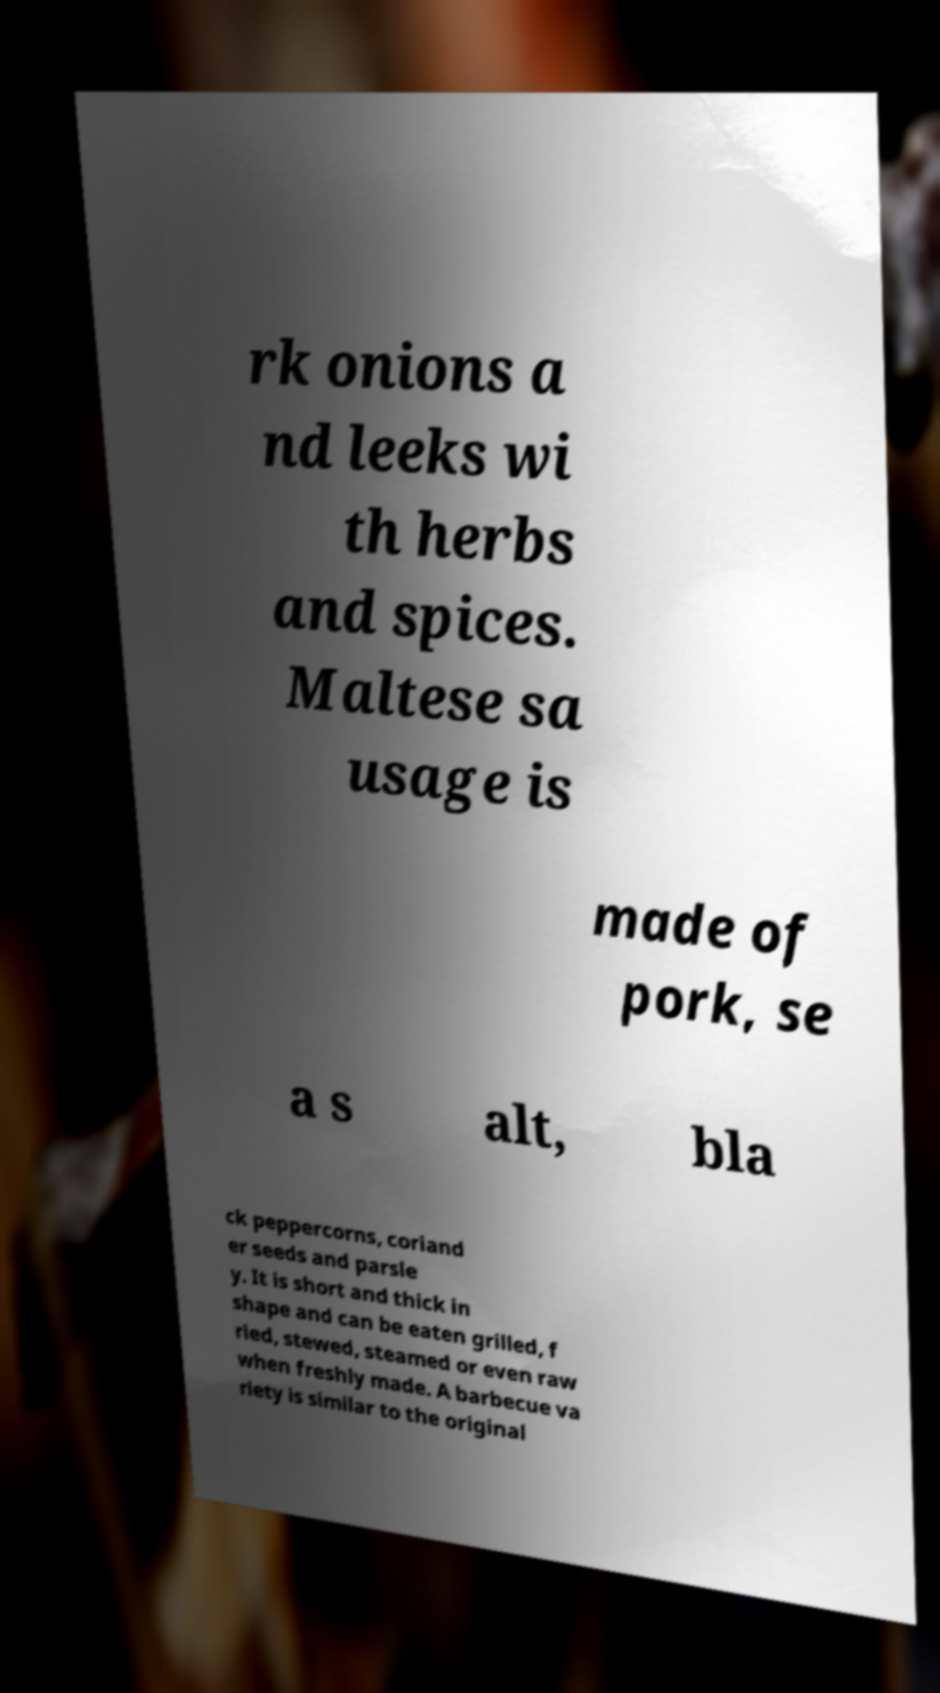I need the written content from this picture converted into text. Can you do that? rk onions a nd leeks wi th herbs and spices. Maltese sa usage is made of pork, se a s alt, bla ck peppercorns, coriand er seeds and parsle y. It is short and thick in shape and can be eaten grilled, f ried, stewed, steamed or even raw when freshly made. A barbecue va riety is similar to the original 